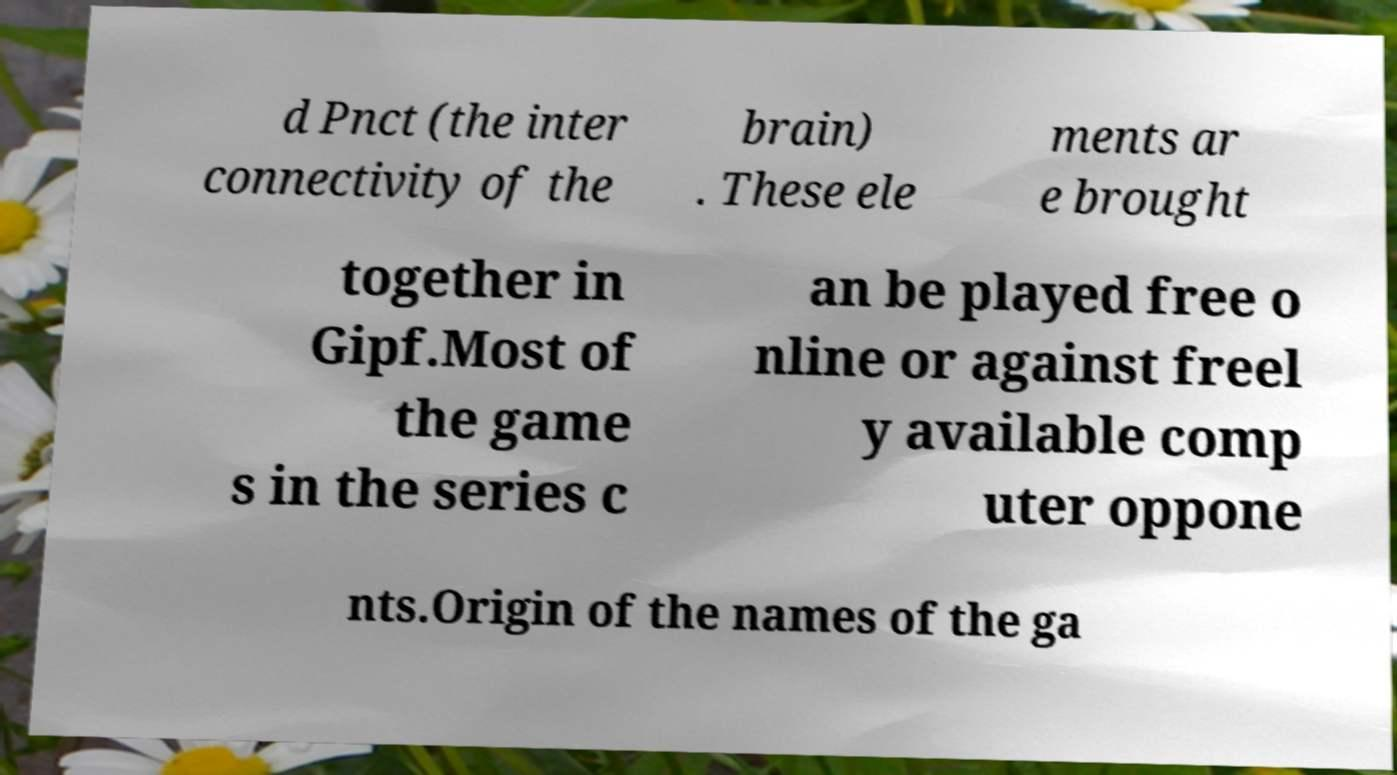There's text embedded in this image that I need extracted. Can you transcribe it verbatim? d Pnct (the inter connectivity of the brain) . These ele ments ar e brought together in Gipf.Most of the game s in the series c an be played free o nline or against freel y available comp uter oppone nts.Origin of the names of the ga 